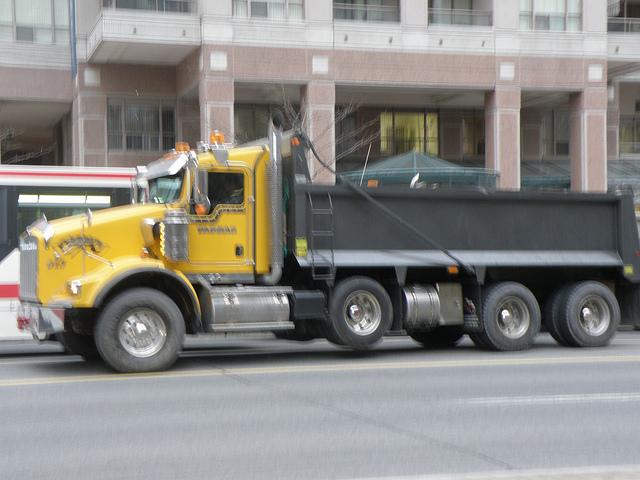Is there a tire off the ground?
Write a very short answer. Yes. Who is driving the yellow truck?
Concise answer only. Truck driver. How many tires do you see?
Be succinct. 4. What kind of truck is this?
Write a very short answer. Dump. What color is the truck?
Quick response, please. Yellow. Is the truck static or kinetic?
Concise answer only. Kinetic. 